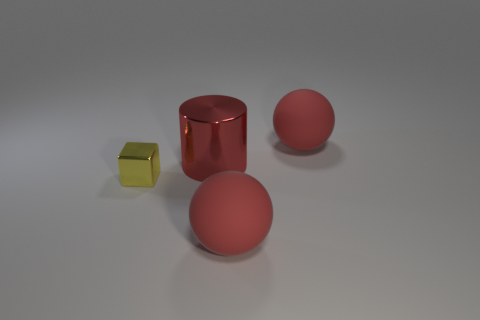What number of other objects are the same material as the small yellow thing?
Your answer should be very brief. 1. There is a thing that is both in front of the red cylinder and on the right side of the small yellow thing; what color is it?
Offer a very short reply. Red. Is the material of the tiny thing the same as the large red ball that is in front of the yellow metallic thing?
Make the answer very short. No. There is a big matte sphere in front of the shiny block that is left of the big red metallic object that is to the right of the small metallic cube; what is its color?
Provide a short and direct response. Red. What number of big balls are made of the same material as the large cylinder?
Provide a short and direct response. 0. There is a ball behind the yellow shiny object; is it the same size as the metallic object that is in front of the large metallic cylinder?
Give a very brief answer. No. There is a big sphere that is behind the tiny yellow thing; what color is it?
Your response must be concise. Red. What number of rubber spheres are the same color as the big shiny cylinder?
Give a very brief answer. 2. There is a yellow shiny thing; is its size the same as the sphere in front of the big metallic cylinder?
Ensure brevity in your answer.  No. There is a block that is left of the red matte object that is behind the large rubber ball that is in front of the large metal cylinder; how big is it?
Provide a succinct answer. Small. 